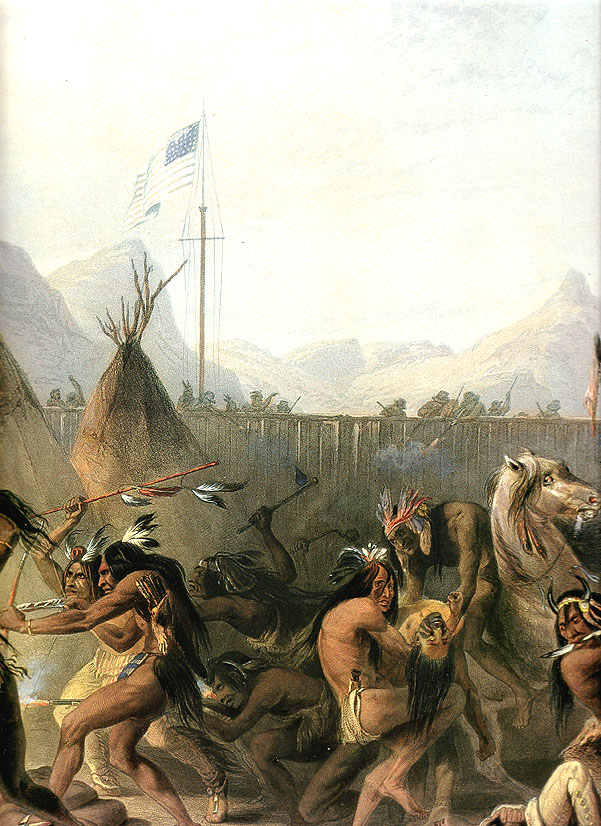What do you think is going on in this snapshot? This image is a historically rich artwork depicting a dynamic and vibrant scene featuring Native Americans engaging in a traditional dance. Central to the image is a tall flagpole bearing an American flag, which adds a touch of blue and red that contrasts with the earth-toned palette of the surroundings. The figures are painted with intricate details, showcasing their traditional attire and headdresses as they perform a dance around the flagpole. The background reveals a serene landscape with tents, mountains, and trees, enhancing the historical and cultural context. The medium used appears to be oil on canvas, giving the painting depth and texture that contribute to the overall immersive experience. The artist masterfully captures the movement, cultural significance, and historical setting, inviting viewers to explore and appreciate this vivid portrayal of Native American heritage. 